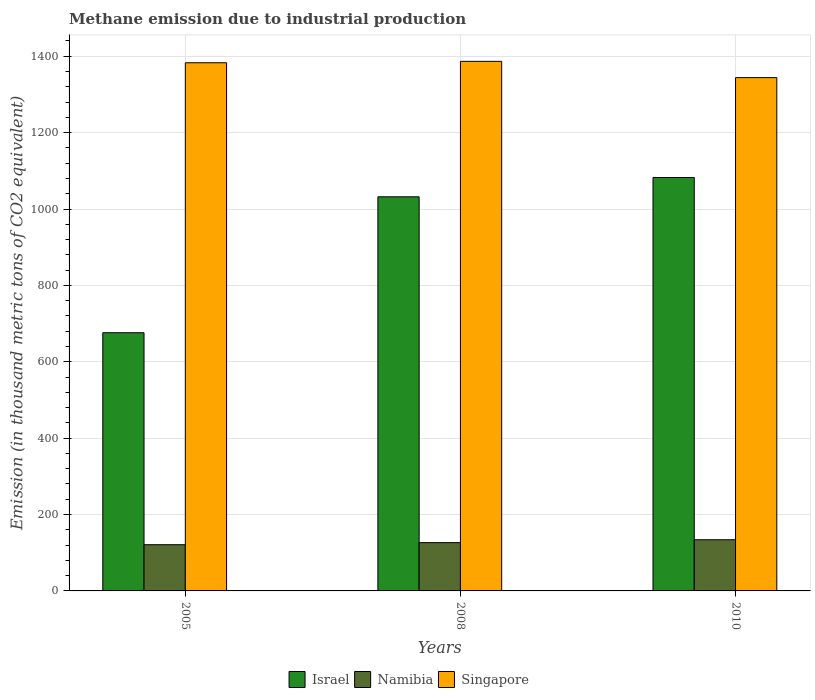How many bars are there on the 3rd tick from the left?
Provide a short and direct response. 3. How many bars are there on the 2nd tick from the right?
Offer a terse response. 3. What is the label of the 1st group of bars from the left?
Make the answer very short. 2005. In how many cases, is the number of bars for a given year not equal to the number of legend labels?
Make the answer very short. 0. What is the amount of methane emitted in Namibia in 2010?
Offer a very short reply. 134. Across all years, what is the maximum amount of methane emitted in Israel?
Ensure brevity in your answer.  1082.5. Across all years, what is the minimum amount of methane emitted in Namibia?
Your answer should be compact. 121. In which year was the amount of methane emitted in Israel maximum?
Provide a short and direct response. 2010. In which year was the amount of methane emitted in Namibia minimum?
Your response must be concise. 2005. What is the total amount of methane emitted in Singapore in the graph?
Offer a terse response. 4113.8. What is the difference between the amount of methane emitted in Singapore in 2005 and that in 2010?
Offer a very short reply. 38.9. What is the difference between the amount of methane emitted in Singapore in 2008 and the amount of methane emitted in Namibia in 2005?
Provide a short and direct response. 1265.7. What is the average amount of methane emitted in Israel per year?
Your answer should be very brief. 930.2. In the year 2005, what is the difference between the amount of methane emitted in Singapore and amount of methane emitted in Namibia?
Offer a very short reply. 1262. In how many years, is the amount of methane emitted in Namibia greater than 1040 thousand metric tons?
Provide a succinct answer. 0. What is the ratio of the amount of methane emitted in Singapore in 2005 to that in 2010?
Give a very brief answer. 1.03. What is the difference between the highest and the second highest amount of methane emitted in Israel?
Keep it short and to the point. 50.5. What is the difference between the highest and the lowest amount of methane emitted in Namibia?
Offer a very short reply. 13. What does the 3rd bar from the left in 2008 represents?
Give a very brief answer. Singapore. What does the 3rd bar from the right in 2010 represents?
Give a very brief answer. Israel. Is it the case that in every year, the sum of the amount of methane emitted in Singapore and amount of methane emitted in Namibia is greater than the amount of methane emitted in Israel?
Make the answer very short. Yes. How many bars are there?
Keep it short and to the point. 9. Are the values on the major ticks of Y-axis written in scientific E-notation?
Provide a short and direct response. No. Does the graph contain any zero values?
Your answer should be compact. No. How many legend labels are there?
Provide a short and direct response. 3. What is the title of the graph?
Your answer should be very brief. Methane emission due to industrial production. Does "Ghana" appear as one of the legend labels in the graph?
Keep it short and to the point. No. What is the label or title of the X-axis?
Make the answer very short. Years. What is the label or title of the Y-axis?
Your answer should be compact. Emission (in thousand metric tons of CO2 equivalent). What is the Emission (in thousand metric tons of CO2 equivalent) in Israel in 2005?
Ensure brevity in your answer.  676.1. What is the Emission (in thousand metric tons of CO2 equivalent) in Namibia in 2005?
Your answer should be very brief. 121. What is the Emission (in thousand metric tons of CO2 equivalent) in Singapore in 2005?
Make the answer very short. 1383. What is the Emission (in thousand metric tons of CO2 equivalent) in Israel in 2008?
Keep it short and to the point. 1032. What is the Emission (in thousand metric tons of CO2 equivalent) in Namibia in 2008?
Ensure brevity in your answer.  126.4. What is the Emission (in thousand metric tons of CO2 equivalent) in Singapore in 2008?
Your answer should be very brief. 1386.7. What is the Emission (in thousand metric tons of CO2 equivalent) of Israel in 2010?
Keep it short and to the point. 1082.5. What is the Emission (in thousand metric tons of CO2 equivalent) in Namibia in 2010?
Give a very brief answer. 134. What is the Emission (in thousand metric tons of CO2 equivalent) in Singapore in 2010?
Keep it short and to the point. 1344.1. Across all years, what is the maximum Emission (in thousand metric tons of CO2 equivalent) in Israel?
Make the answer very short. 1082.5. Across all years, what is the maximum Emission (in thousand metric tons of CO2 equivalent) of Namibia?
Your response must be concise. 134. Across all years, what is the maximum Emission (in thousand metric tons of CO2 equivalent) in Singapore?
Provide a short and direct response. 1386.7. Across all years, what is the minimum Emission (in thousand metric tons of CO2 equivalent) in Israel?
Ensure brevity in your answer.  676.1. Across all years, what is the minimum Emission (in thousand metric tons of CO2 equivalent) of Namibia?
Keep it short and to the point. 121. Across all years, what is the minimum Emission (in thousand metric tons of CO2 equivalent) of Singapore?
Offer a terse response. 1344.1. What is the total Emission (in thousand metric tons of CO2 equivalent) of Israel in the graph?
Your answer should be compact. 2790.6. What is the total Emission (in thousand metric tons of CO2 equivalent) of Namibia in the graph?
Your answer should be compact. 381.4. What is the total Emission (in thousand metric tons of CO2 equivalent) of Singapore in the graph?
Make the answer very short. 4113.8. What is the difference between the Emission (in thousand metric tons of CO2 equivalent) of Israel in 2005 and that in 2008?
Your response must be concise. -355.9. What is the difference between the Emission (in thousand metric tons of CO2 equivalent) of Israel in 2005 and that in 2010?
Give a very brief answer. -406.4. What is the difference between the Emission (in thousand metric tons of CO2 equivalent) of Namibia in 2005 and that in 2010?
Ensure brevity in your answer.  -13. What is the difference between the Emission (in thousand metric tons of CO2 equivalent) of Singapore in 2005 and that in 2010?
Provide a succinct answer. 38.9. What is the difference between the Emission (in thousand metric tons of CO2 equivalent) in Israel in 2008 and that in 2010?
Provide a short and direct response. -50.5. What is the difference between the Emission (in thousand metric tons of CO2 equivalent) in Singapore in 2008 and that in 2010?
Offer a very short reply. 42.6. What is the difference between the Emission (in thousand metric tons of CO2 equivalent) in Israel in 2005 and the Emission (in thousand metric tons of CO2 equivalent) in Namibia in 2008?
Give a very brief answer. 549.7. What is the difference between the Emission (in thousand metric tons of CO2 equivalent) of Israel in 2005 and the Emission (in thousand metric tons of CO2 equivalent) of Singapore in 2008?
Your answer should be very brief. -710.6. What is the difference between the Emission (in thousand metric tons of CO2 equivalent) in Namibia in 2005 and the Emission (in thousand metric tons of CO2 equivalent) in Singapore in 2008?
Ensure brevity in your answer.  -1265.7. What is the difference between the Emission (in thousand metric tons of CO2 equivalent) in Israel in 2005 and the Emission (in thousand metric tons of CO2 equivalent) in Namibia in 2010?
Provide a succinct answer. 542.1. What is the difference between the Emission (in thousand metric tons of CO2 equivalent) in Israel in 2005 and the Emission (in thousand metric tons of CO2 equivalent) in Singapore in 2010?
Give a very brief answer. -668. What is the difference between the Emission (in thousand metric tons of CO2 equivalent) in Namibia in 2005 and the Emission (in thousand metric tons of CO2 equivalent) in Singapore in 2010?
Provide a succinct answer. -1223.1. What is the difference between the Emission (in thousand metric tons of CO2 equivalent) of Israel in 2008 and the Emission (in thousand metric tons of CO2 equivalent) of Namibia in 2010?
Make the answer very short. 898. What is the difference between the Emission (in thousand metric tons of CO2 equivalent) in Israel in 2008 and the Emission (in thousand metric tons of CO2 equivalent) in Singapore in 2010?
Offer a terse response. -312.1. What is the difference between the Emission (in thousand metric tons of CO2 equivalent) of Namibia in 2008 and the Emission (in thousand metric tons of CO2 equivalent) of Singapore in 2010?
Make the answer very short. -1217.7. What is the average Emission (in thousand metric tons of CO2 equivalent) of Israel per year?
Offer a very short reply. 930.2. What is the average Emission (in thousand metric tons of CO2 equivalent) in Namibia per year?
Keep it short and to the point. 127.13. What is the average Emission (in thousand metric tons of CO2 equivalent) of Singapore per year?
Ensure brevity in your answer.  1371.27. In the year 2005, what is the difference between the Emission (in thousand metric tons of CO2 equivalent) of Israel and Emission (in thousand metric tons of CO2 equivalent) of Namibia?
Your answer should be compact. 555.1. In the year 2005, what is the difference between the Emission (in thousand metric tons of CO2 equivalent) in Israel and Emission (in thousand metric tons of CO2 equivalent) in Singapore?
Your answer should be very brief. -706.9. In the year 2005, what is the difference between the Emission (in thousand metric tons of CO2 equivalent) in Namibia and Emission (in thousand metric tons of CO2 equivalent) in Singapore?
Offer a terse response. -1262. In the year 2008, what is the difference between the Emission (in thousand metric tons of CO2 equivalent) in Israel and Emission (in thousand metric tons of CO2 equivalent) in Namibia?
Ensure brevity in your answer.  905.6. In the year 2008, what is the difference between the Emission (in thousand metric tons of CO2 equivalent) in Israel and Emission (in thousand metric tons of CO2 equivalent) in Singapore?
Keep it short and to the point. -354.7. In the year 2008, what is the difference between the Emission (in thousand metric tons of CO2 equivalent) of Namibia and Emission (in thousand metric tons of CO2 equivalent) of Singapore?
Your response must be concise. -1260.3. In the year 2010, what is the difference between the Emission (in thousand metric tons of CO2 equivalent) in Israel and Emission (in thousand metric tons of CO2 equivalent) in Namibia?
Your response must be concise. 948.5. In the year 2010, what is the difference between the Emission (in thousand metric tons of CO2 equivalent) in Israel and Emission (in thousand metric tons of CO2 equivalent) in Singapore?
Provide a short and direct response. -261.6. In the year 2010, what is the difference between the Emission (in thousand metric tons of CO2 equivalent) of Namibia and Emission (in thousand metric tons of CO2 equivalent) of Singapore?
Keep it short and to the point. -1210.1. What is the ratio of the Emission (in thousand metric tons of CO2 equivalent) of Israel in 2005 to that in 2008?
Provide a succinct answer. 0.66. What is the ratio of the Emission (in thousand metric tons of CO2 equivalent) in Namibia in 2005 to that in 2008?
Your answer should be compact. 0.96. What is the ratio of the Emission (in thousand metric tons of CO2 equivalent) in Singapore in 2005 to that in 2008?
Ensure brevity in your answer.  1. What is the ratio of the Emission (in thousand metric tons of CO2 equivalent) in Israel in 2005 to that in 2010?
Keep it short and to the point. 0.62. What is the ratio of the Emission (in thousand metric tons of CO2 equivalent) in Namibia in 2005 to that in 2010?
Offer a terse response. 0.9. What is the ratio of the Emission (in thousand metric tons of CO2 equivalent) in Singapore in 2005 to that in 2010?
Ensure brevity in your answer.  1.03. What is the ratio of the Emission (in thousand metric tons of CO2 equivalent) in Israel in 2008 to that in 2010?
Provide a short and direct response. 0.95. What is the ratio of the Emission (in thousand metric tons of CO2 equivalent) in Namibia in 2008 to that in 2010?
Give a very brief answer. 0.94. What is the ratio of the Emission (in thousand metric tons of CO2 equivalent) of Singapore in 2008 to that in 2010?
Your response must be concise. 1.03. What is the difference between the highest and the second highest Emission (in thousand metric tons of CO2 equivalent) in Israel?
Your response must be concise. 50.5. What is the difference between the highest and the lowest Emission (in thousand metric tons of CO2 equivalent) of Israel?
Provide a succinct answer. 406.4. What is the difference between the highest and the lowest Emission (in thousand metric tons of CO2 equivalent) in Namibia?
Keep it short and to the point. 13. What is the difference between the highest and the lowest Emission (in thousand metric tons of CO2 equivalent) in Singapore?
Offer a very short reply. 42.6. 